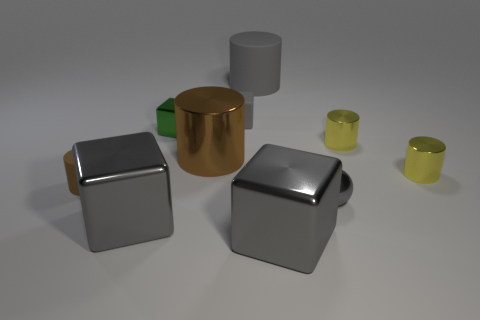Subtract all gray cylinders. How many cylinders are left? 4 Subtract all purple cylinders. How many gray cubes are left? 3 Subtract 3 cylinders. How many cylinders are left? 2 Subtract all gray cylinders. How many cylinders are left? 4 Add 6 large gray matte things. How many large gray matte things are left? 7 Add 3 red blocks. How many red blocks exist? 3 Subtract 0 red blocks. How many objects are left? 10 Subtract all spheres. How many objects are left? 9 Subtract all purple spheres. Subtract all green cylinders. How many spheres are left? 1 Subtract all big gray rubber things. Subtract all small brown rubber cylinders. How many objects are left? 8 